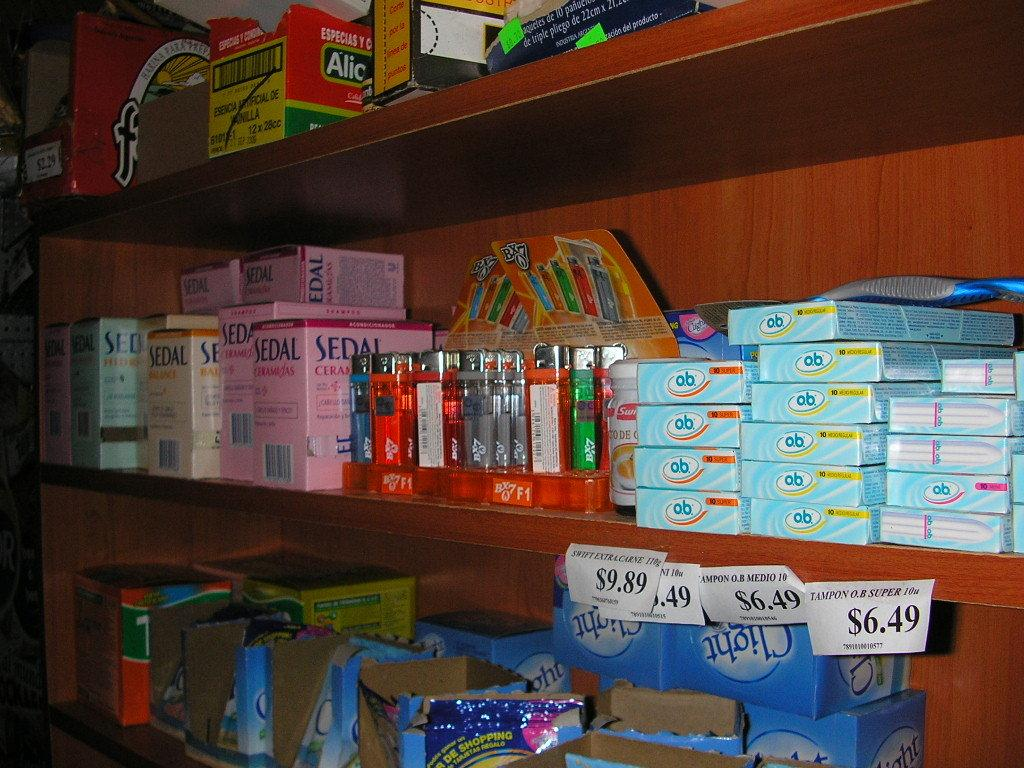<image>
Create a compact narrative representing the image presented. Different products are crowded onto wooden shelves including OB tampons and cigarette lighters. 